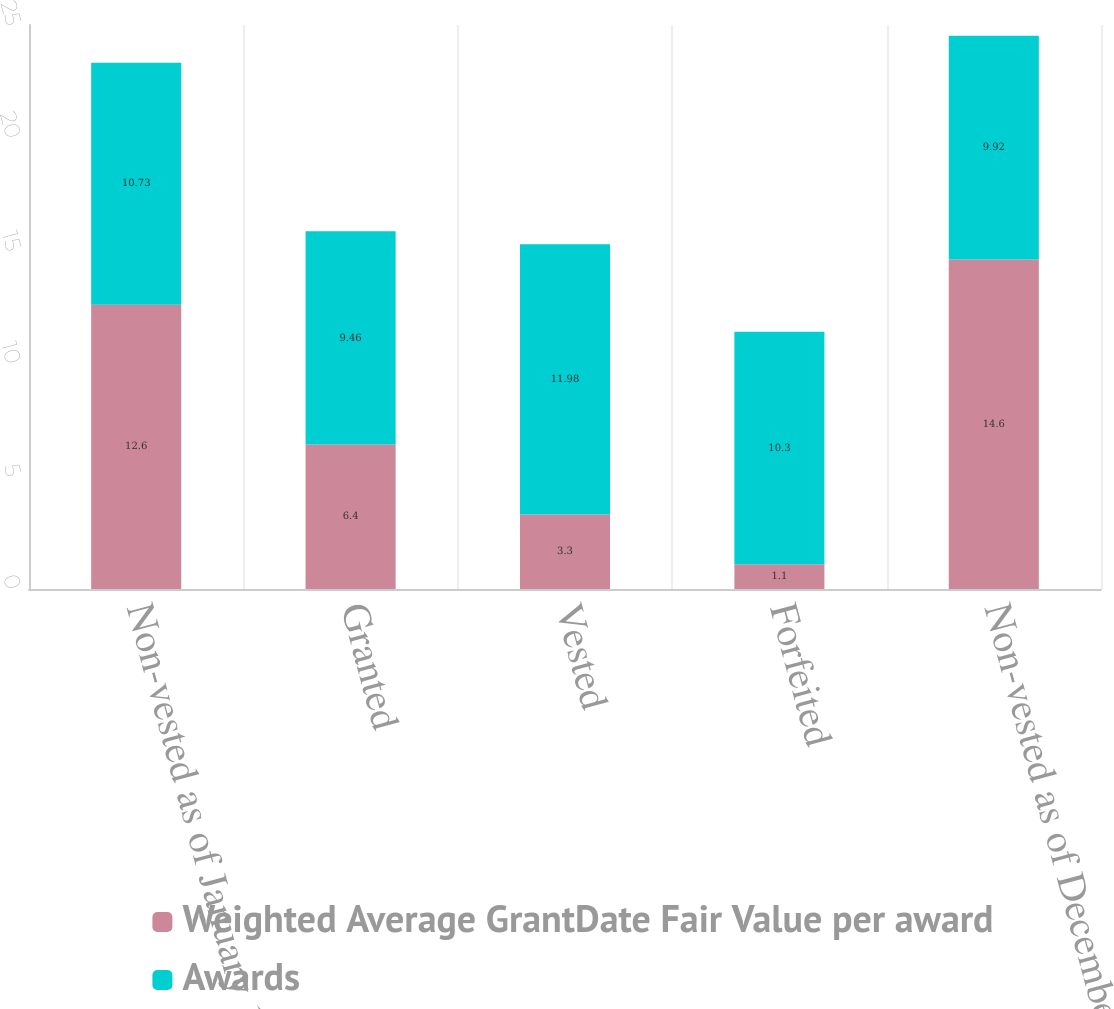Convert chart to OTSL. <chart><loc_0><loc_0><loc_500><loc_500><stacked_bar_chart><ecel><fcel>Non-vested as of January 1<fcel>Granted<fcel>Vested<fcel>Forfeited<fcel>Non-vested as of December 31<nl><fcel>Weighted Average GrantDate Fair Value per award<fcel>12.6<fcel>6.4<fcel>3.3<fcel>1.1<fcel>14.6<nl><fcel>Awards<fcel>10.73<fcel>9.46<fcel>11.98<fcel>10.3<fcel>9.92<nl></chart> 